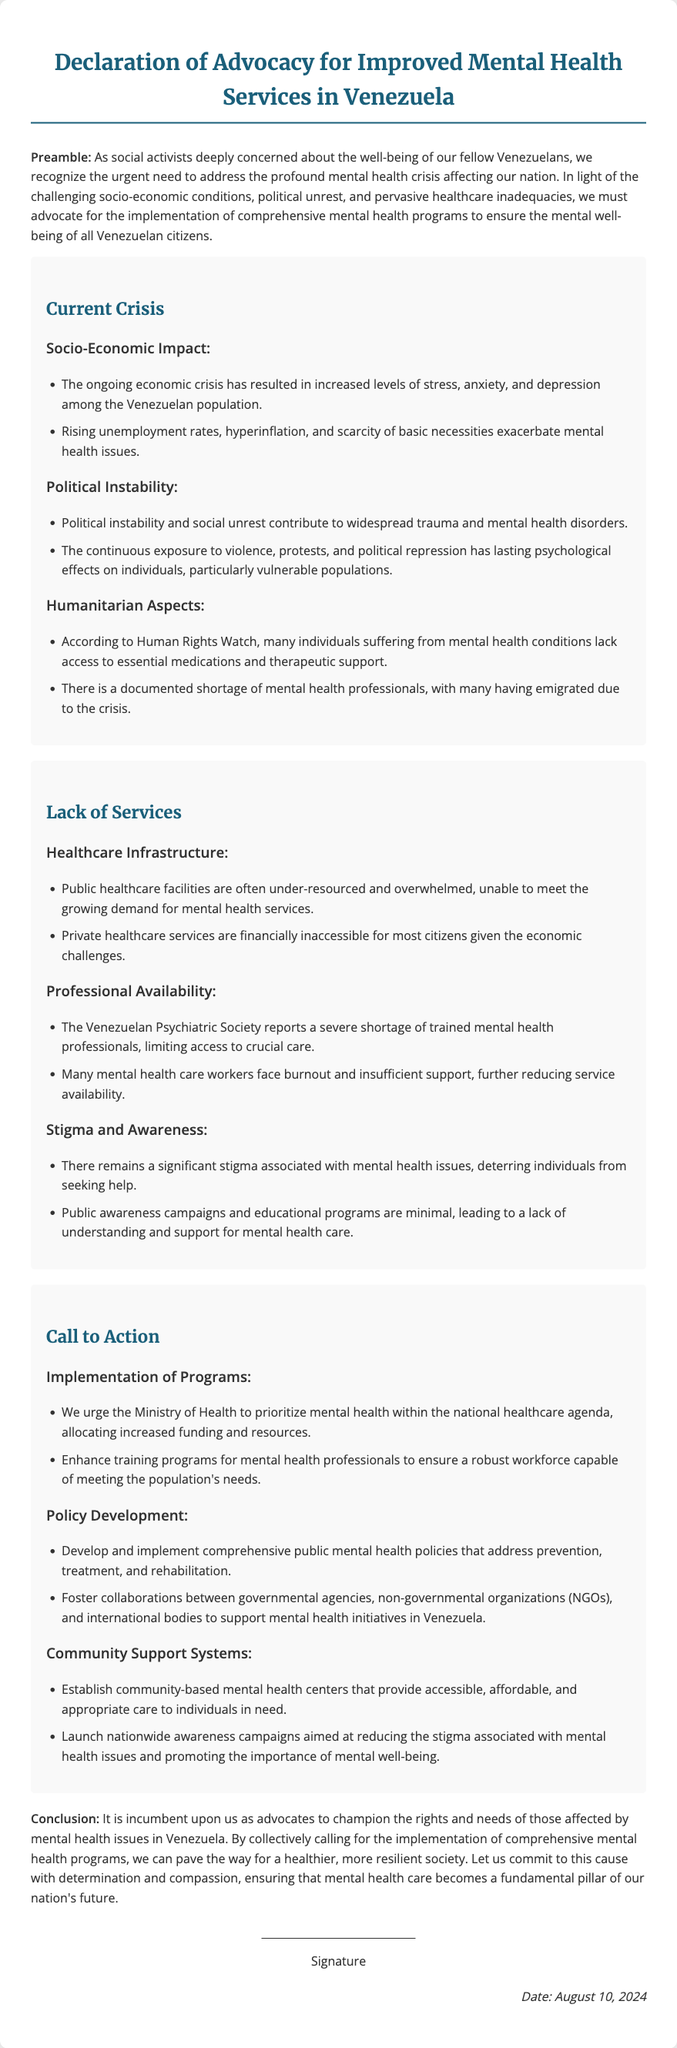What is the title of the document? The title is stated at the top of the document, clearly indicating the purpose of the Declaration.
Answer: Declaration of Advocacy for Improved Mental Health Services in Venezuela What is one reason for the mental health crisis in Venezuela? The document lists multiple factors contributing to the crisis, including socio-economic impacts.
Answer: Increased levels of stress, anxiety, and depression What organization reports a shortage of mental health professionals? The name of the organization is mentioned in the document, highlighting their observation regarding the workforce in mental health care.
Answer: Venezuelan Psychiatric Society What is one suggested step towards improving mental health services? The document includes various calls to action for enhancing mental health services in Venezuela, specifically related to governmental priorities.
Answer: Prioritize mental health within the national healthcare agenda What is the date mentioned in the document? The date is dynamically generated within the document and reflects when it is being viewed, indicating the relevance of the advocacy.
Answer: Current date (variable) What impact does political instability have according to the document? The document explains the effects of political turmoil and unrest on mental health, leading to specific issues.
Answer: Contribute to widespread trauma and mental health disorders What type of support does the document call for from the Ministry of Health? The document directly urges specific actions from the Ministry, detailing the necessary support for mental health.
Answer: Increased funding and resources What are community-based mental health centers meant to provide? This part of the document outlines the goals for establishing such centers, focusing on accessibility and care.
Answer: Accessible, affordable, and appropriate care 